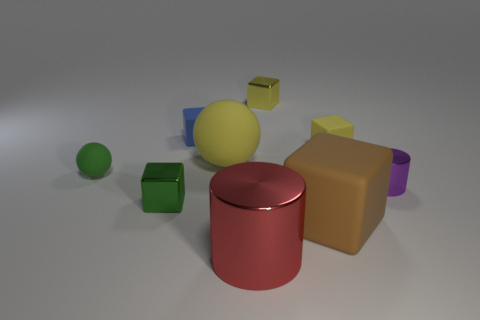What color is the large thing that is the same shape as the small green metal object?
Your answer should be very brief. Brown. How many small cubes are the same color as the tiny metallic cylinder?
Ensure brevity in your answer.  0. Is the number of blue rubber blocks that are to the left of the small yellow metallic cube greater than the number of green rubber spheres?
Your answer should be compact. No. What is the color of the small shiny block that is in front of the yellow matte object that is to the right of the yellow metal thing?
Ensure brevity in your answer.  Green. What number of objects are either metal cylinders that are right of the red metal cylinder or yellow rubber cubes in front of the blue rubber thing?
Give a very brief answer. 2. What color is the tiny matte sphere?
Give a very brief answer. Green. How many tiny green cylinders are made of the same material as the large block?
Make the answer very short. 0. Are there more big yellow balls than large blue objects?
Offer a terse response. Yes. How many green shiny cubes are on the right side of the tiny matte cube that is right of the brown rubber thing?
Give a very brief answer. 0. How many objects are either tiny purple metal objects that are in front of the tiny matte sphere or tiny matte objects?
Ensure brevity in your answer.  4. 